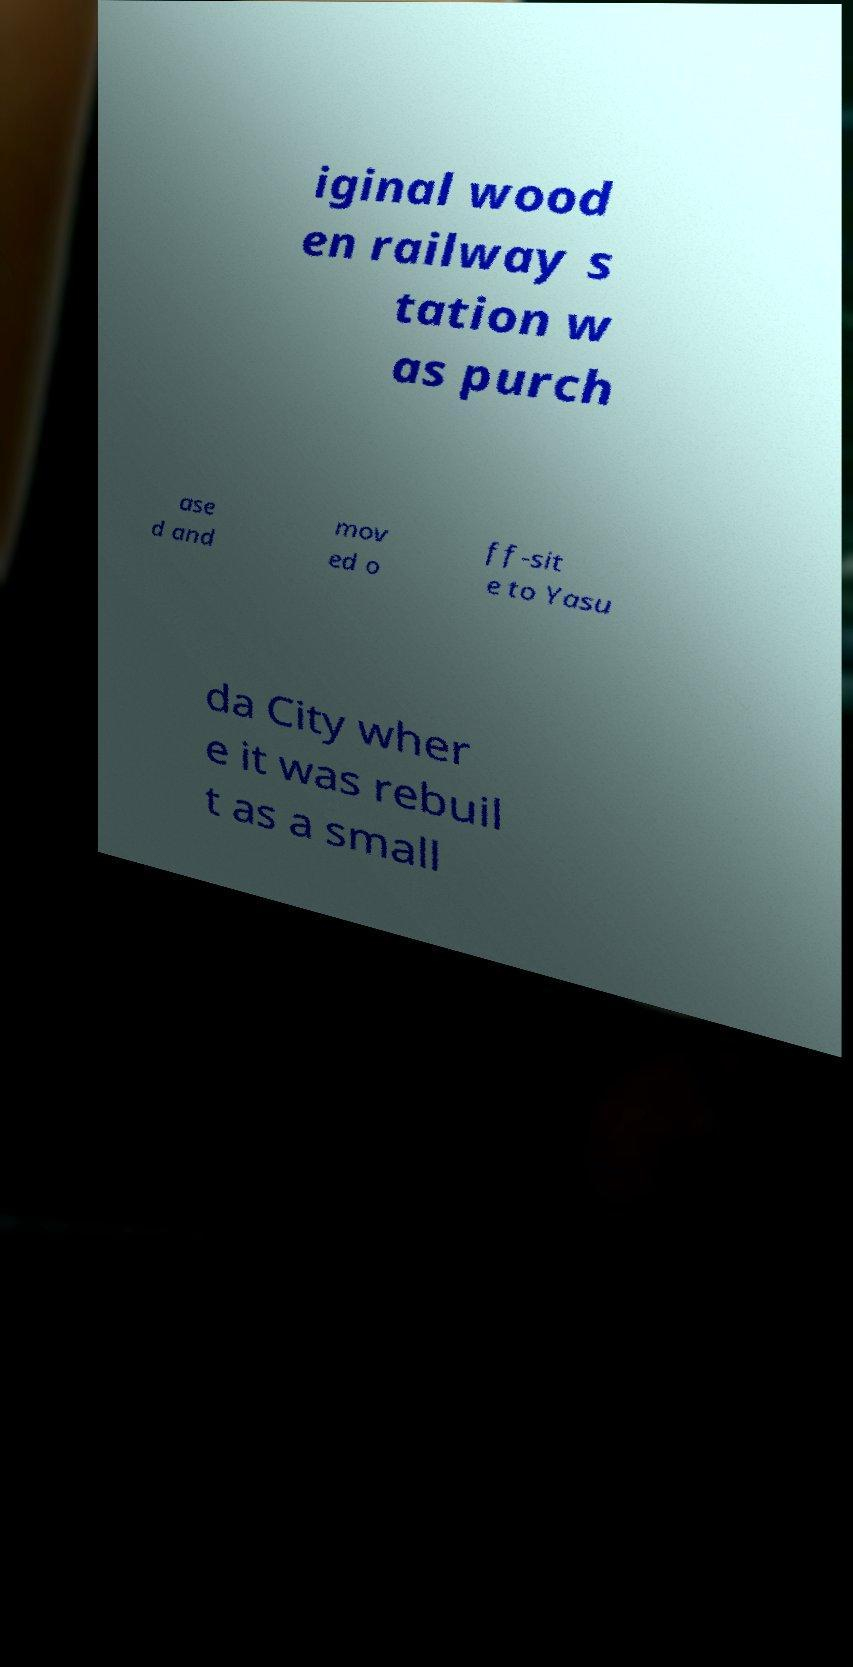For documentation purposes, I need the text within this image transcribed. Could you provide that? iginal wood en railway s tation w as purch ase d and mov ed o ff-sit e to Yasu da City wher e it was rebuil t as a small 